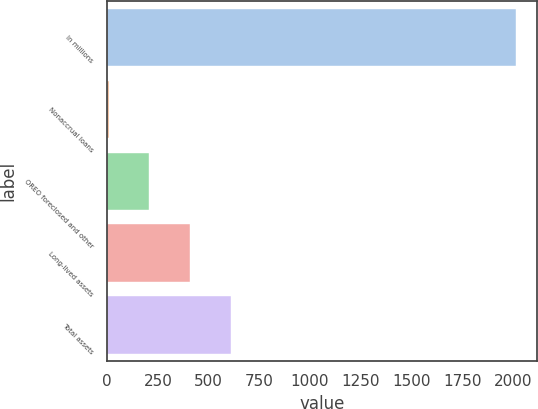Convert chart to OTSL. <chart><loc_0><loc_0><loc_500><loc_500><bar_chart><fcel>In millions<fcel>Nonaccrual loans<fcel>OREO foreclosed and other<fcel>Long-lived assets<fcel>Total assets<nl><fcel>2017<fcel>8<fcel>208.9<fcel>409.8<fcel>610.7<nl></chart> 